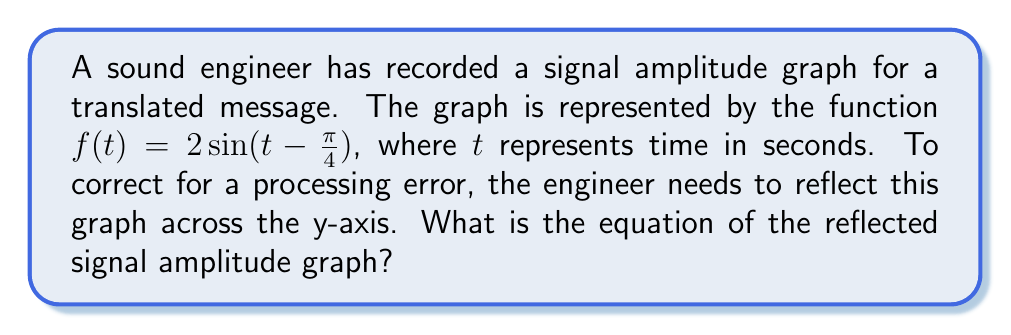What is the answer to this math problem? To reflect a graph across the y-axis, we need to replace every $t$ in the original function with $-t$. This process can be broken down into steps:

1. Start with the original function: $f(t) = 2\sin(t-\frac{\pi}{4})$

2. Replace every $t$ with $-t$:
   $f(-t) = 2\sin(-t-\frac{\pi}{4})$

3. Simplify the argument of the sine function:
   $f(-t) = 2\sin(-t-\frac{\pi}{4})$
   $= 2\sin(-(t+\frac{\pi}{4}))$

4. Use the property of odd functions that $\sin(-x) = -\sin(x)$:
   $f(-t) = 2(-\sin(t+\frac{\pi}{4}))$
   $= -2\sin(t+\frac{\pi}{4})$

5. This is our final reflected function. We can verify that:
   - The amplitude remains 2
   - The phase shift has changed from $-\frac{\pi}{4}$ to $+\frac{\pi}{4}$
   - The negative sign in front indicates a vertical reflection, which combined with the horizontal reflection across the y-axis, results in the original shape but shifted
Answer: The equation of the reflected signal amplitude graph is $f(t) = -2\sin(t+\frac{\pi}{4})$. 